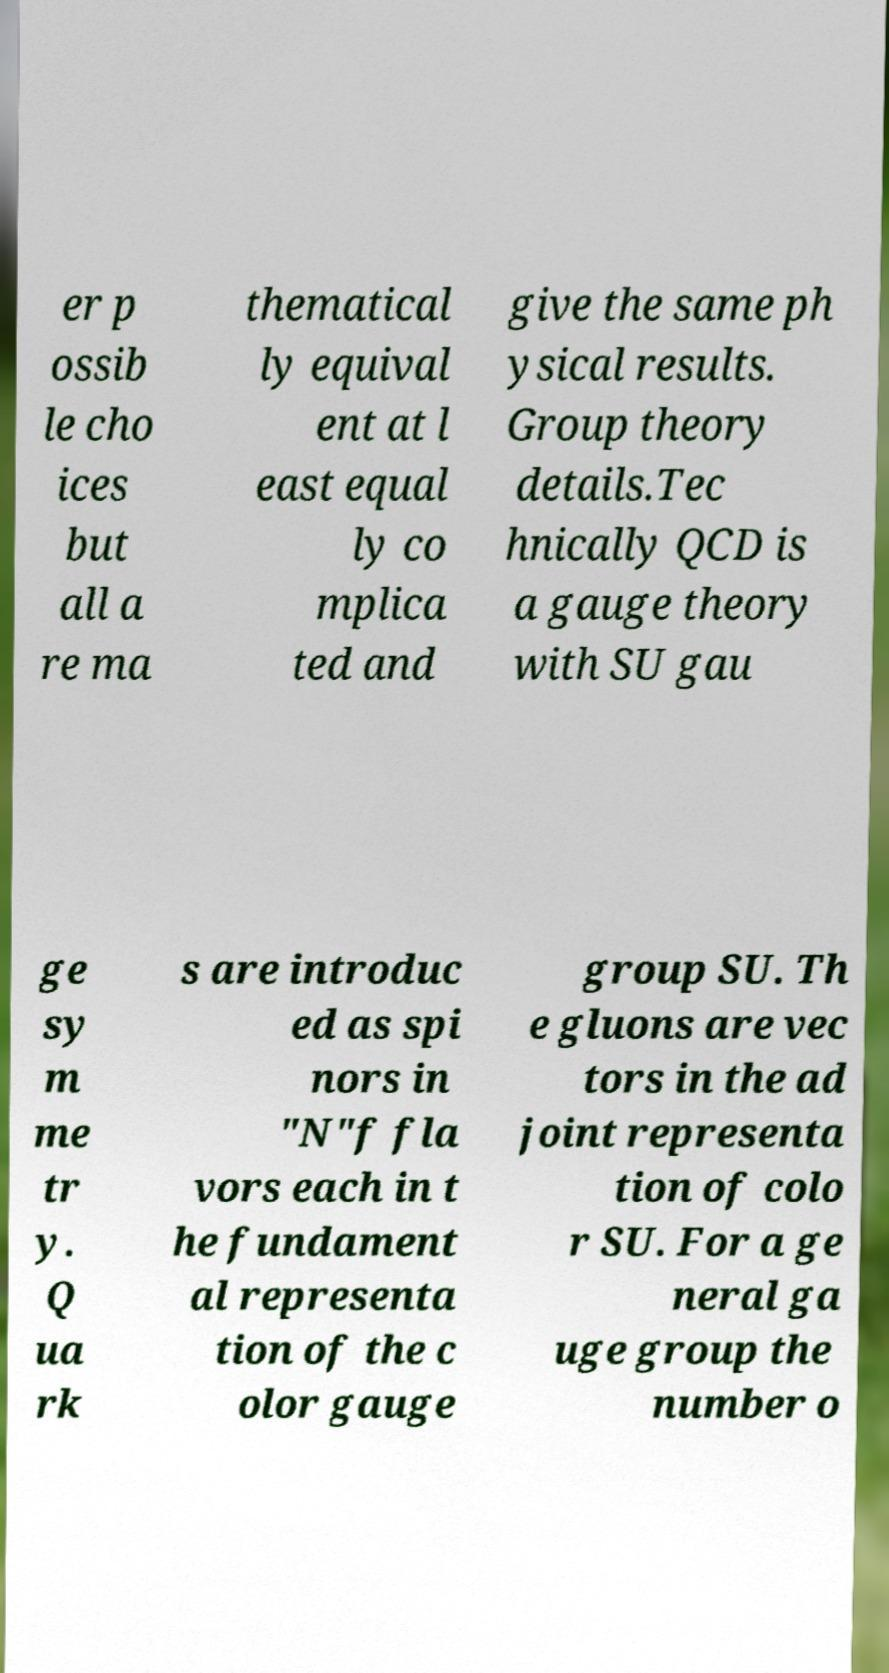Can you read and provide the text displayed in the image?This photo seems to have some interesting text. Can you extract and type it out for me? er p ossib le cho ices but all a re ma thematical ly equival ent at l east equal ly co mplica ted and give the same ph ysical results. Group theory details.Tec hnically QCD is a gauge theory with SU gau ge sy m me tr y. Q ua rk s are introduc ed as spi nors in "N"f fla vors each in t he fundament al representa tion of the c olor gauge group SU. Th e gluons are vec tors in the ad joint representa tion of colo r SU. For a ge neral ga uge group the number o 